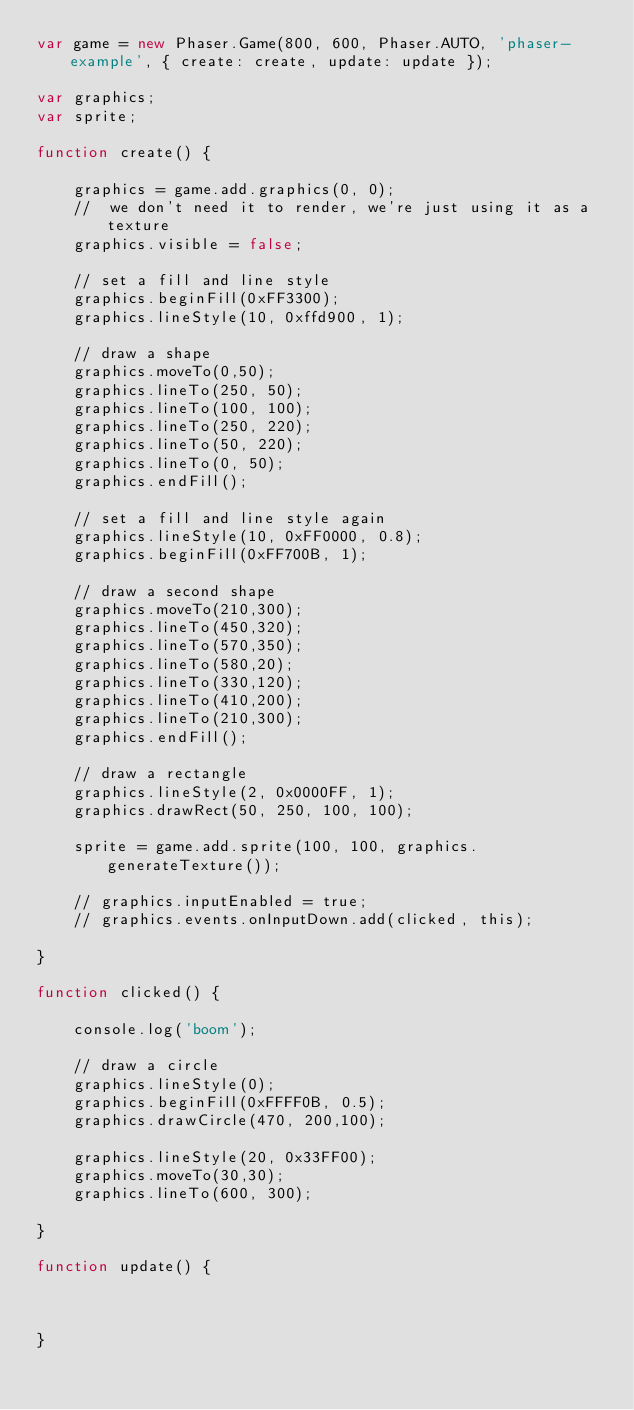Convert code to text. <code><loc_0><loc_0><loc_500><loc_500><_JavaScript_>var game = new Phaser.Game(800, 600, Phaser.AUTO, 'phaser-example', { create: create, update: update });

var graphics;
var sprite;

function create() {

    graphics = game.add.graphics(0, 0);
    //  we don't need it to render, we're just using it as a texture
    graphics.visible = false;

    // set a fill and line style
    graphics.beginFill(0xFF3300);
    graphics.lineStyle(10, 0xffd900, 1);
    
    // draw a shape
    graphics.moveTo(0,50);
    graphics.lineTo(250, 50);
    graphics.lineTo(100, 100);
    graphics.lineTo(250, 220);
    graphics.lineTo(50, 220);
    graphics.lineTo(0, 50);
    graphics.endFill();
    
    // set a fill and line style again
    graphics.lineStyle(10, 0xFF0000, 0.8);
    graphics.beginFill(0xFF700B, 1);
    
    // draw a second shape
    graphics.moveTo(210,300);
    graphics.lineTo(450,320);
    graphics.lineTo(570,350);
    graphics.lineTo(580,20);
    graphics.lineTo(330,120);
    graphics.lineTo(410,200);
    graphics.lineTo(210,300);
    graphics.endFill();
    
    // draw a rectangle
    graphics.lineStyle(2, 0x0000FF, 1);
    graphics.drawRect(50, 250, 100, 100);
    
    sprite = game.add.sprite(100, 100, graphics.generateTexture());

    // graphics.inputEnabled = true;
    // graphics.events.onInputDown.add(clicked, this);

}

function clicked() {

    console.log('boom');

    // draw a circle
    graphics.lineStyle(0);
    graphics.beginFill(0xFFFF0B, 0.5);
    graphics.drawCircle(470, 200,100);
    
    graphics.lineStyle(20, 0x33FF00);
    graphics.moveTo(30,30);
    graphics.lineTo(600, 300);

}

function update() {



}</code> 